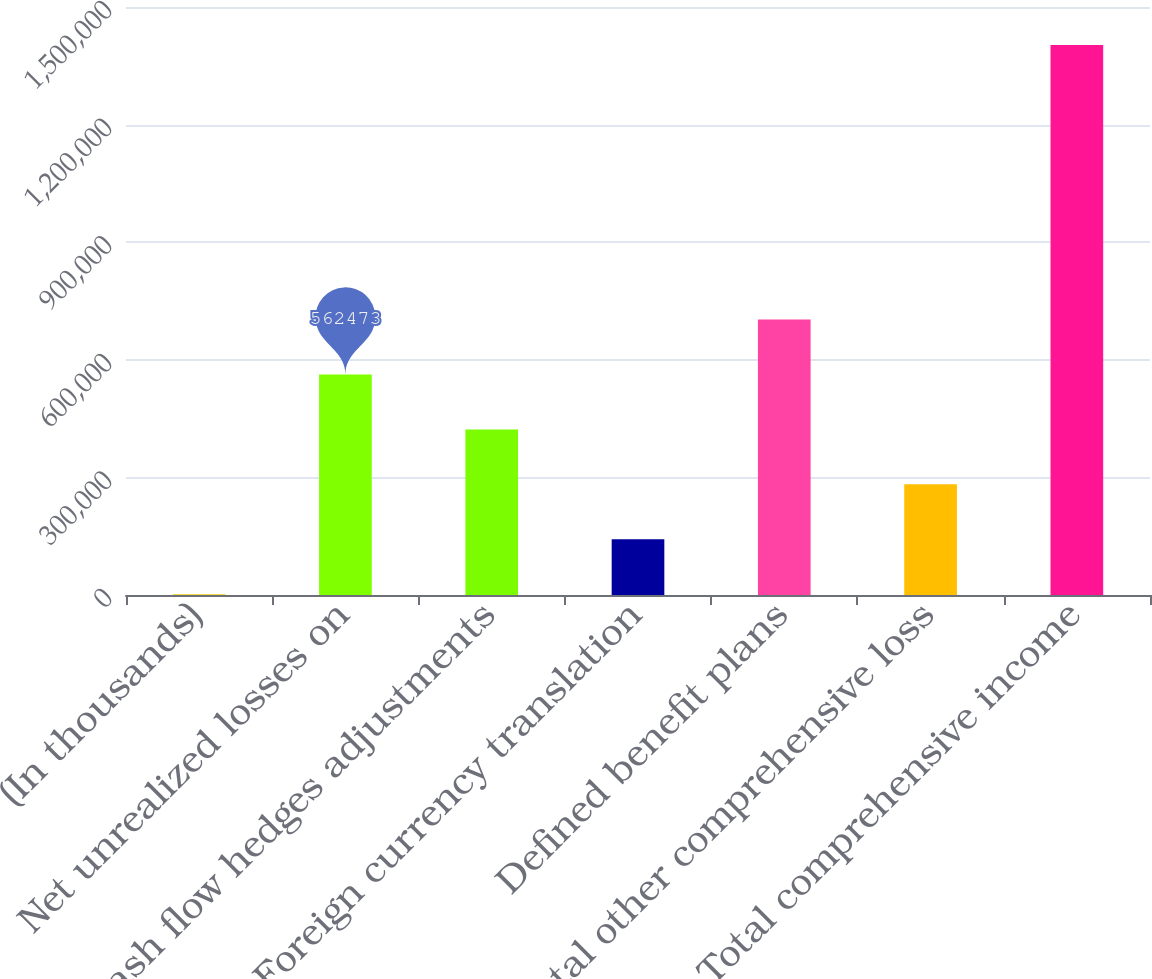Convert chart to OTSL. <chart><loc_0><loc_0><loc_500><loc_500><bar_chart><fcel>(In thousands)<fcel>Net unrealized losses on<fcel>Cash flow hedges adjustments<fcel>Foreign currency translation<fcel>Defined benefit plans<fcel>Total other comprehensive loss<fcel>Total comprehensive income<nl><fcel>2017<fcel>562473<fcel>422359<fcel>142131<fcel>702587<fcel>282245<fcel>1.40316e+06<nl></chart> 